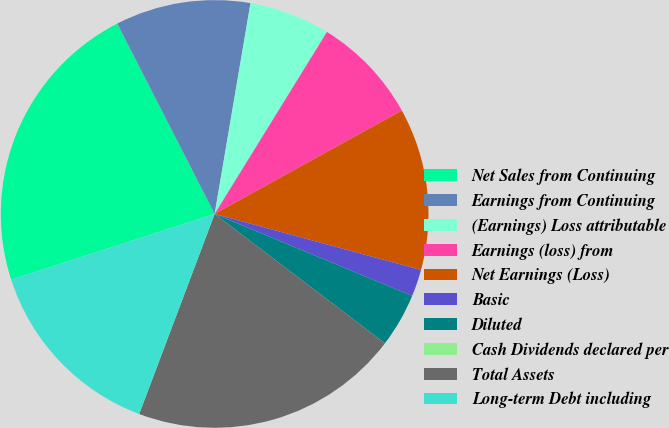Convert chart to OTSL. <chart><loc_0><loc_0><loc_500><loc_500><pie_chart><fcel>Net Sales from Continuing<fcel>Earnings from Continuing<fcel>(Earnings) Loss attributable<fcel>Earnings (loss) from<fcel>Net Earnings (Loss)<fcel>Basic<fcel>Diluted<fcel>Cash Dividends declared per<fcel>Total Assets<fcel>Long-term Debt including<nl><fcel>22.44%<fcel>10.21%<fcel>6.12%<fcel>8.17%<fcel>12.25%<fcel>2.04%<fcel>4.08%<fcel>0.0%<fcel>20.4%<fcel>14.29%<nl></chart> 